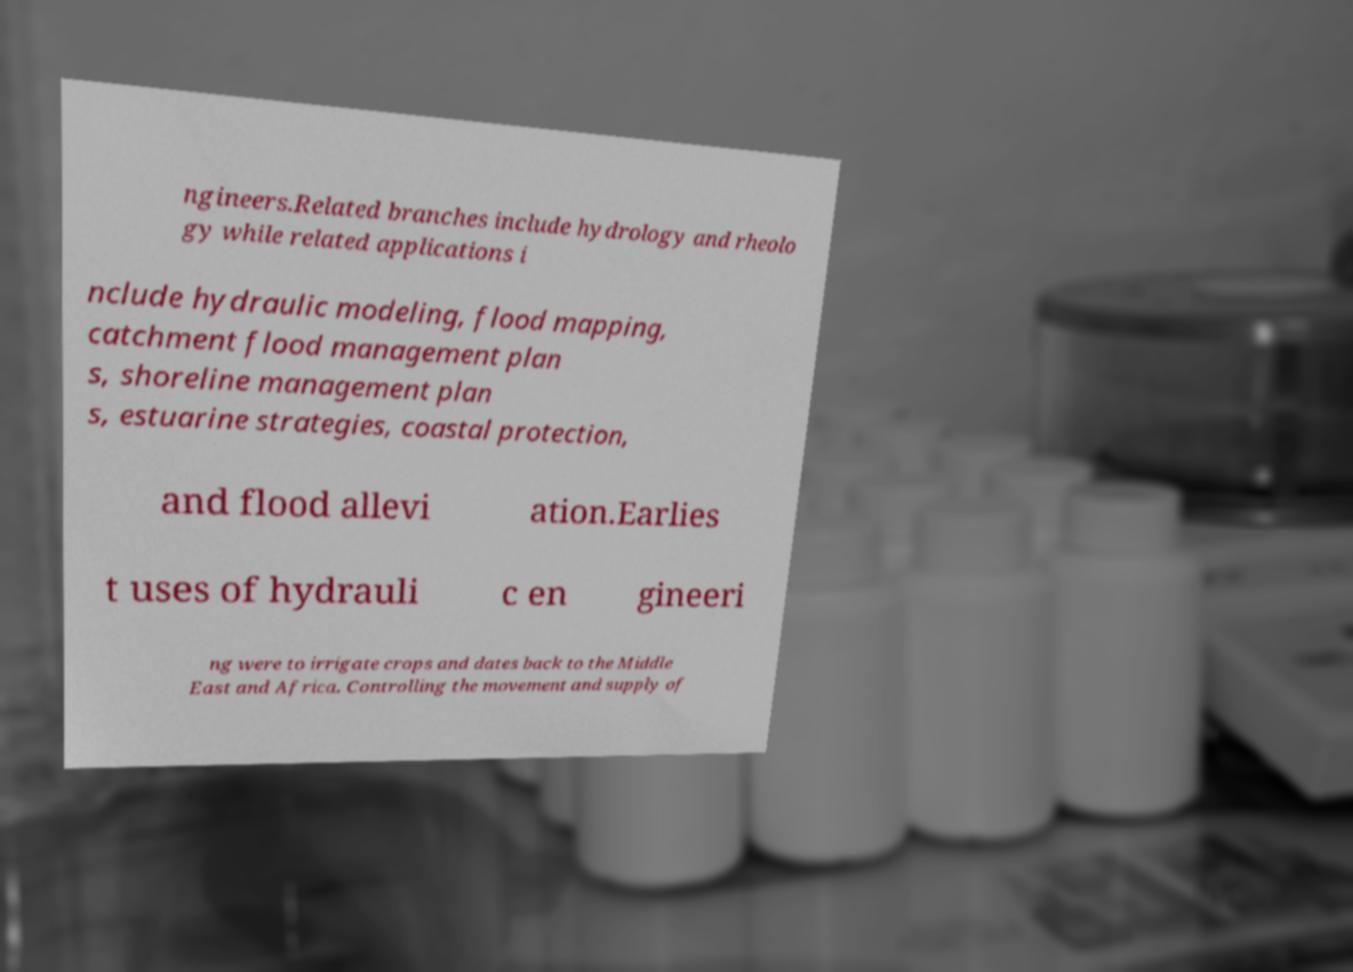Can you accurately transcribe the text from the provided image for me? ngineers.Related branches include hydrology and rheolo gy while related applications i nclude hydraulic modeling, flood mapping, catchment flood management plan s, shoreline management plan s, estuarine strategies, coastal protection, and flood allevi ation.Earlies t uses of hydrauli c en gineeri ng were to irrigate crops and dates back to the Middle East and Africa. Controlling the movement and supply of 